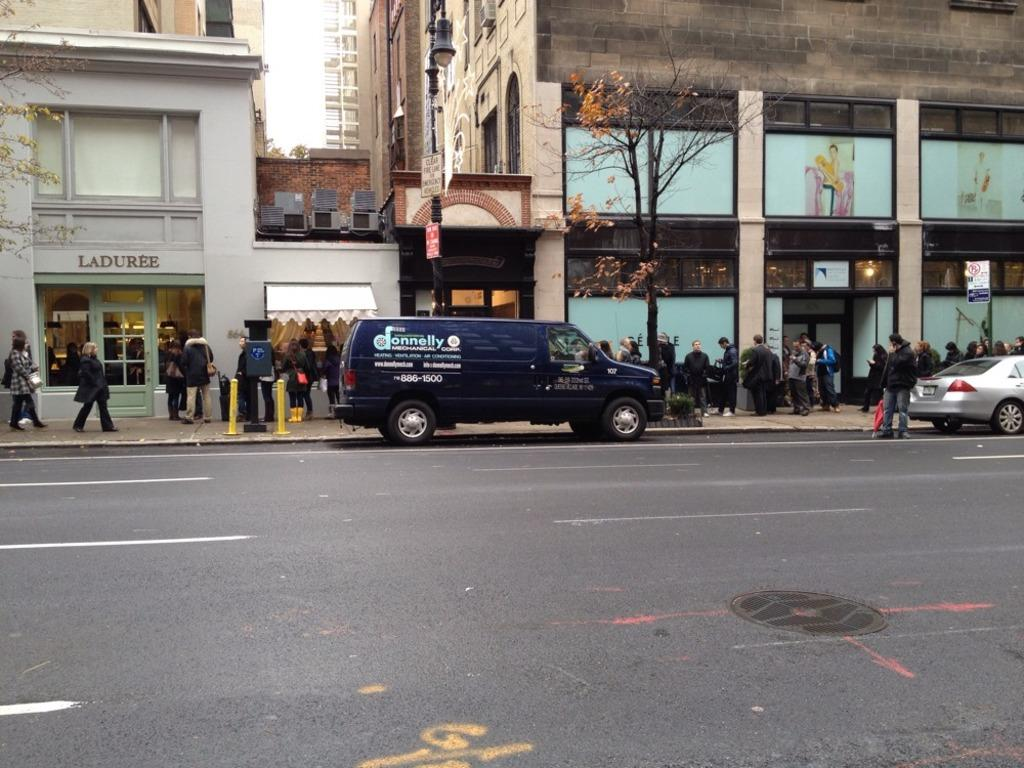<image>
Present a compact description of the photo's key features. A street with the store Laduree and a large amount of pedestrians. 